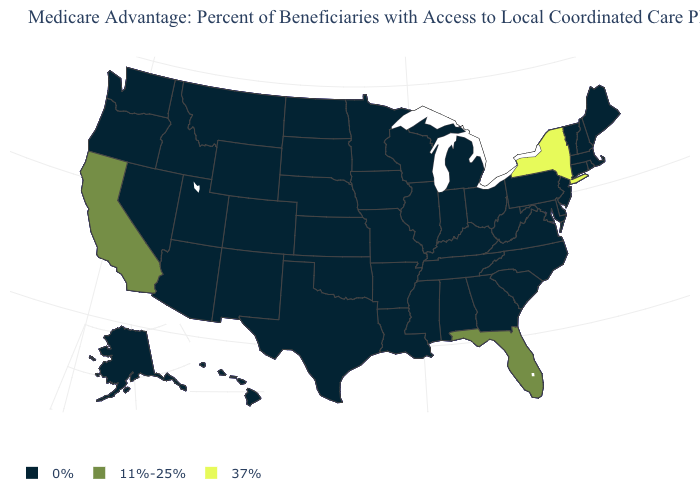What is the highest value in the USA?
Keep it brief. 37%. What is the value of Alaska?
Keep it brief. 0%. Does the map have missing data?
Answer briefly. No. Among the states that border Maine , which have the lowest value?
Keep it brief. New Hampshire. How many symbols are there in the legend?
Write a very short answer. 3. What is the value of Delaware?
Quick response, please. 0%. Which states have the highest value in the USA?
Write a very short answer. New York. What is the highest value in states that border Louisiana?
Concise answer only. 0%. Does South Carolina have the lowest value in the USA?
Concise answer only. Yes. How many symbols are there in the legend?
Quick response, please. 3. Does South Carolina have the highest value in the South?
Keep it brief. No. Among the states that border Virginia , which have the lowest value?
Keep it brief. Kentucky, Maryland, North Carolina, Tennessee, West Virginia. Name the states that have a value in the range 11%-25%?
Write a very short answer. California, Florida. What is the value of South Carolina?
Write a very short answer. 0%. Name the states that have a value in the range 37%?
Short answer required. New York. 